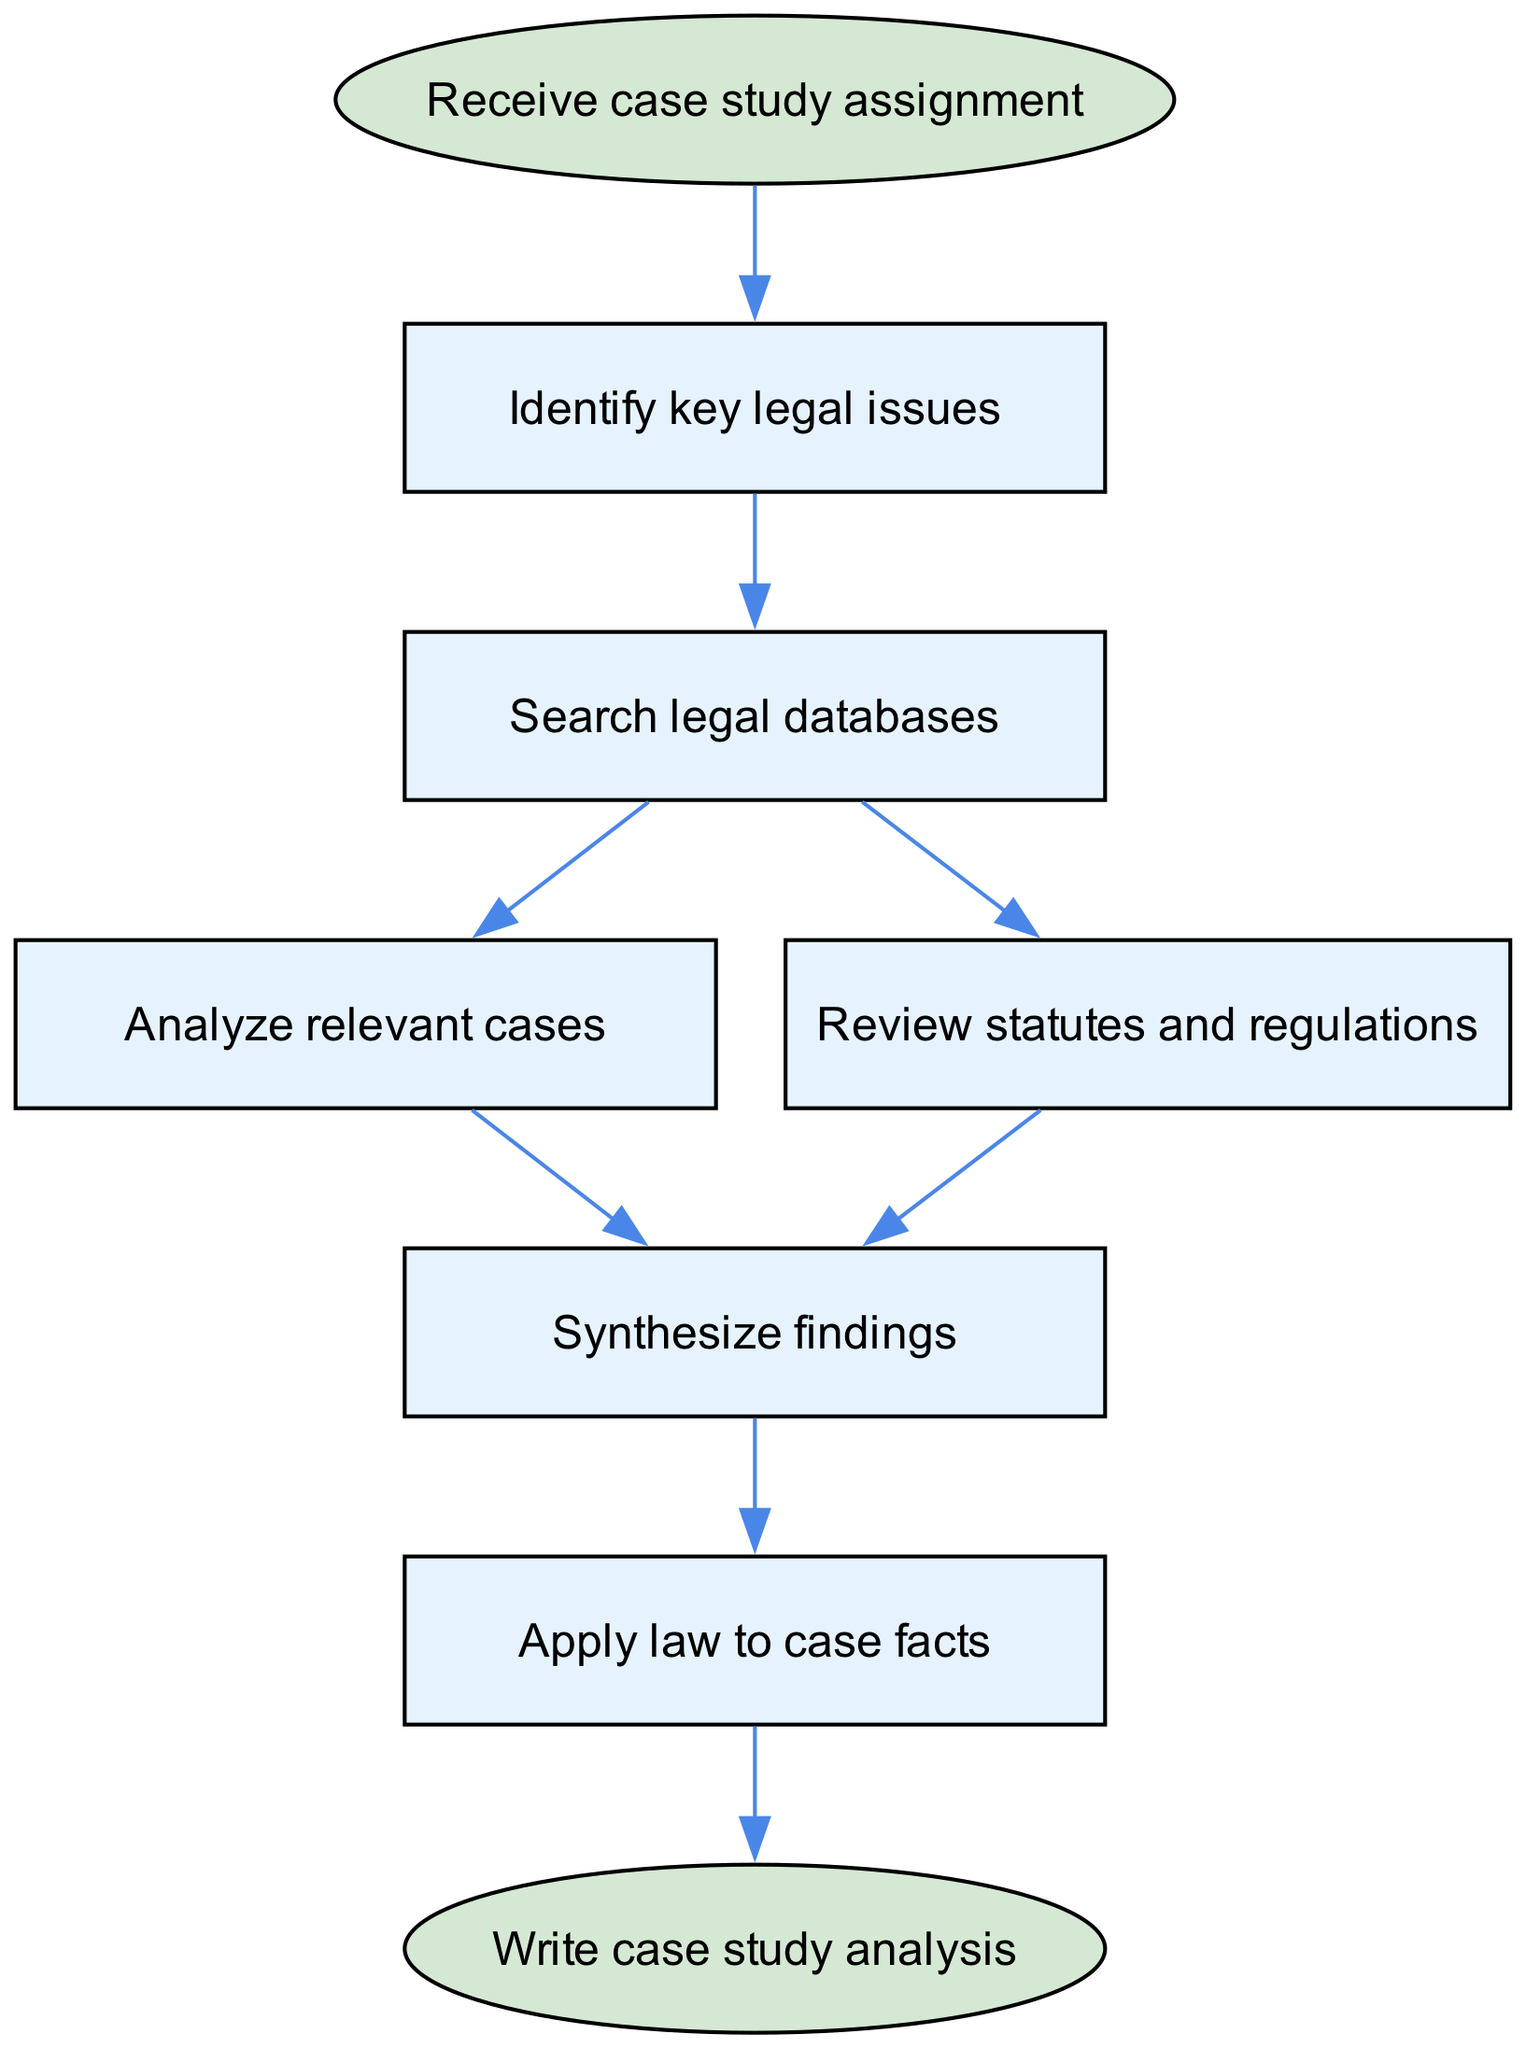What is the first step in the legal research process? The first step is indicated as "Receive case study assignment," which is the starting node of the flowchart.
Answer: Receive case study assignment How many nodes are present in the flowchart? The flowchart contains 8 nodes, including both the start and end nodes, as listed in the nodes section of the data.
Answer: 8 What is the last step before writing the case study analysis? The last step before writing the case study analysis is "Apply law to case facts," which is shown just before the final node in the flowchart.
Answer: Apply law to case facts Which two steps are directly connected to the "Search legal databases" node? The two steps directly connected to "Search legal databases" are "Analyze relevant cases" and "Review statutes and regulations," indicating that after searching, both analysis and review can occur simultaneously.
Answer: Analyze relevant cases, Review statutes and regulations What node follows "Synthesize findings"? The node that follows "Synthesize findings" is "Apply law to case facts," demonstrating the progression from synthesis to practical application in the legal research process.
Answer: Apply law to case facts Which step involves reviewing legal statutes? The step involving reviewing legal statutes is "Review statutes and regulations," explicitly mentioned as a distinct process in the diagram.
Answer: Review statutes and regulations In which order must the steps "Analyze relevant cases" and "Review statutes and regulations" be completed? Both "Analyze relevant cases" and "Review statutes and regulations" are side by side in the flowchart after "Search legal databases," indicating that they can be completed in parallel before moving to the synthesis stage.
Answer: Indeterminate (can be done in parallel) What is the relationship between "Identify key legal issues" and "Synthesize findings"? "Identify key legal issues" is the first step before moving to "Search legal databases," while "Synthesize findings" comes after analyzing cases and reviewing statutes, showing that identifying issues initiates the overall flow leading to synthesis.
Answer: Sequential relationship (Identify, Search, Analyze/Review, Synthesize) 